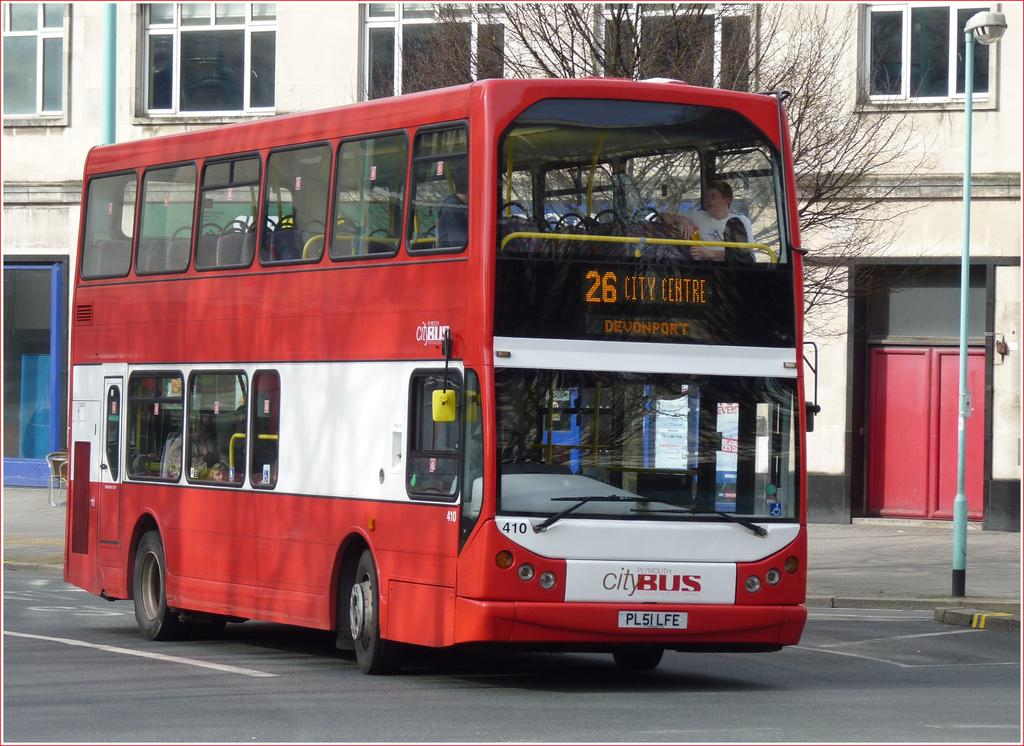Provide a one-sentence caption for the provided image. A doubledecker bus that stops at 26 City Centre. 